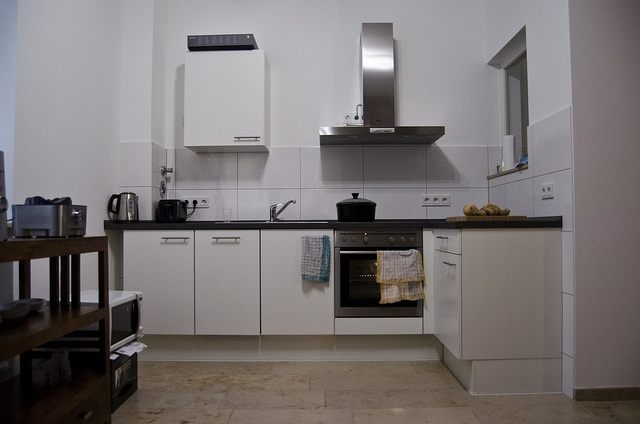Describe the objects in this image and their specific colors. I can see oven in gray and black tones, microwave in gray, black, and darkgray tones, toaster in gray, black, and darkgray tones, banana in gray, olive, and black tones, and sink in gray, black, and darkgray tones in this image. 